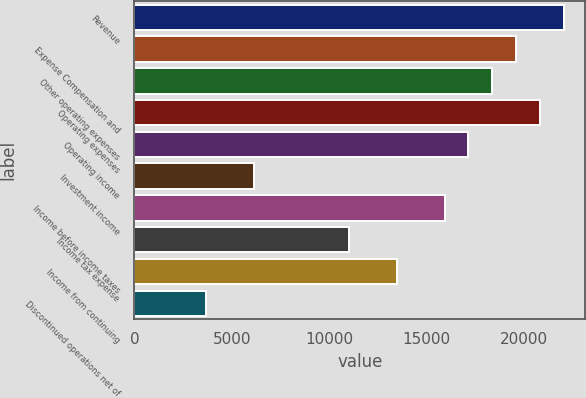Convert chart. <chart><loc_0><loc_0><loc_500><loc_500><bar_chart><fcel>Revenue<fcel>Expense Compensation and<fcel>Other operating expenses<fcel>Operating expenses<fcel>Operating income<fcel>Investment income<fcel>Income before income taxes<fcel>Income tax expense<fcel>Income from continuing<fcel>Discontinued operations net of<nl><fcel>22067.9<fcel>19616.2<fcel>18390.3<fcel>20842<fcel>17164.5<fcel>6131.72<fcel>15938.6<fcel>11035.2<fcel>13486.9<fcel>3680<nl></chart> 